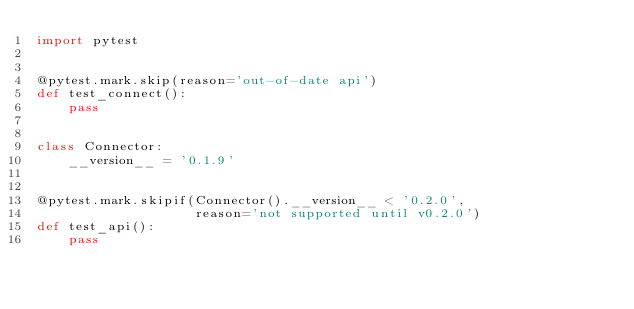Convert code to text. <code><loc_0><loc_0><loc_500><loc_500><_Python_>import pytest


@pytest.mark.skip(reason='out-of-date api')
def test_connect():
    pass


class Connector:
    __version__ = '0.1.9'


@pytest.mark.skipif(Connector().__version__ < '0.2.0',
                    reason='not supported until v0.2.0')
def test_api():
    pass
</code> 